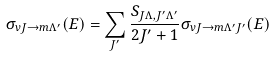Convert formula to latex. <formula><loc_0><loc_0><loc_500><loc_500>\sigma _ { v J \rightarrow m \Lambda ^ { \prime } } ( E ) = \sum _ { J ^ { \prime } } \frac { S _ { J \Lambda , J ^ { \prime } \Lambda ^ { \prime } } } { 2 J ^ { \prime } + 1 } \sigma _ { v J \rightarrow m \Lambda ^ { \prime } J ^ { \prime } } ( E )</formula> 